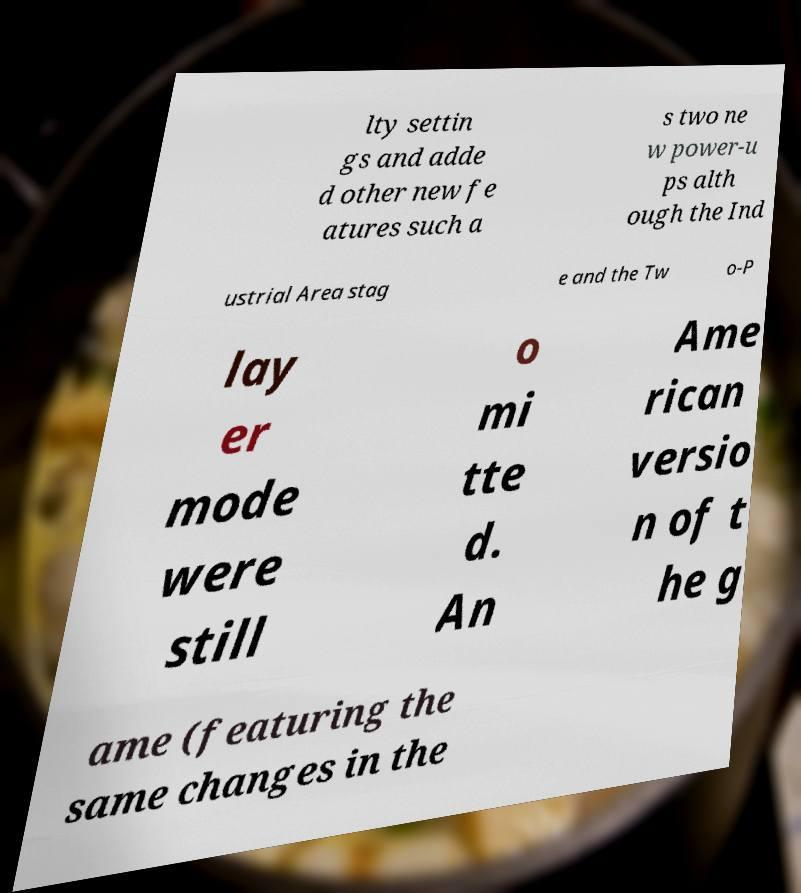There's text embedded in this image that I need extracted. Can you transcribe it verbatim? lty settin gs and adde d other new fe atures such a s two ne w power-u ps alth ough the Ind ustrial Area stag e and the Tw o-P lay er mode were still o mi tte d. An Ame rican versio n of t he g ame (featuring the same changes in the 